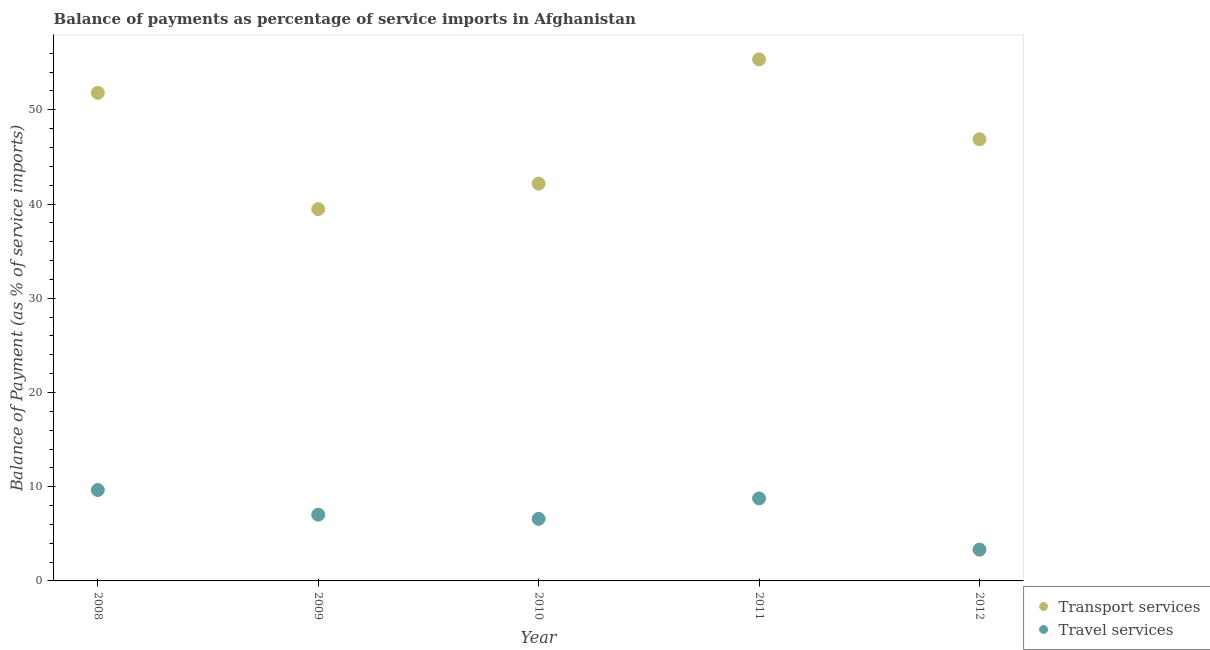Is the number of dotlines equal to the number of legend labels?
Keep it short and to the point. Yes. What is the balance of payments of transport services in 2008?
Give a very brief answer. 51.81. Across all years, what is the maximum balance of payments of travel services?
Ensure brevity in your answer.  9.65. Across all years, what is the minimum balance of payments of travel services?
Your response must be concise. 3.32. What is the total balance of payments of transport services in the graph?
Your response must be concise. 235.67. What is the difference between the balance of payments of travel services in 2008 and that in 2011?
Provide a short and direct response. 0.89. What is the difference between the balance of payments of transport services in 2012 and the balance of payments of travel services in 2009?
Offer a very short reply. 39.84. What is the average balance of payments of transport services per year?
Provide a succinct answer. 47.13. In the year 2012, what is the difference between the balance of payments of transport services and balance of payments of travel services?
Provide a short and direct response. 43.56. What is the ratio of the balance of payments of transport services in 2008 to that in 2010?
Ensure brevity in your answer.  1.23. Is the difference between the balance of payments of transport services in 2008 and 2009 greater than the difference between the balance of payments of travel services in 2008 and 2009?
Make the answer very short. Yes. What is the difference between the highest and the second highest balance of payments of travel services?
Give a very brief answer. 0.89. What is the difference between the highest and the lowest balance of payments of travel services?
Offer a terse response. 6.33. Is the sum of the balance of payments of travel services in 2009 and 2012 greater than the maximum balance of payments of transport services across all years?
Keep it short and to the point. No. Does the balance of payments of transport services monotonically increase over the years?
Offer a very short reply. No. Is the balance of payments of travel services strictly greater than the balance of payments of transport services over the years?
Provide a succinct answer. No. Is the balance of payments of travel services strictly less than the balance of payments of transport services over the years?
Offer a terse response. Yes. How many dotlines are there?
Keep it short and to the point. 2. Are the values on the major ticks of Y-axis written in scientific E-notation?
Offer a terse response. No. Does the graph contain grids?
Give a very brief answer. No. How are the legend labels stacked?
Give a very brief answer. Vertical. What is the title of the graph?
Make the answer very short. Balance of payments as percentage of service imports in Afghanistan. What is the label or title of the Y-axis?
Keep it short and to the point. Balance of Payment (as % of service imports). What is the Balance of Payment (as % of service imports) in Transport services in 2008?
Your response must be concise. 51.81. What is the Balance of Payment (as % of service imports) of Travel services in 2008?
Give a very brief answer. 9.65. What is the Balance of Payment (as % of service imports) in Transport services in 2009?
Offer a terse response. 39.46. What is the Balance of Payment (as % of service imports) in Travel services in 2009?
Offer a very short reply. 7.03. What is the Balance of Payment (as % of service imports) in Transport services in 2010?
Keep it short and to the point. 42.17. What is the Balance of Payment (as % of service imports) of Travel services in 2010?
Provide a succinct answer. 6.59. What is the Balance of Payment (as % of service imports) of Transport services in 2011?
Offer a terse response. 55.35. What is the Balance of Payment (as % of service imports) of Travel services in 2011?
Your response must be concise. 8.75. What is the Balance of Payment (as % of service imports) of Transport services in 2012?
Your response must be concise. 46.87. What is the Balance of Payment (as % of service imports) of Travel services in 2012?
Ensure brevity in your answer.  3.32. Across all years, what is the maximum Balance of Payment (as % of service imports) in Transport services?
Make the answer very short. 55.35. Across all years, what is the maximum Balance of Payment (as % of service imports) of Travel services?
Your response must be concise. 9.65. Across all years, what is the minimum Balance of Payment (as % of service imports) of Transport services?
Your answer should be compact. 39.46. Across all years, what is the minimum Balance of Payment (as % of service imports) of Travel services?
Provide a short and direct response. 3.32. What is the total Balance of Payment (as % of service imports) of Transport services in the graph?
Your answer should be compact. 235.67. What is the total Balance of Payment (as % of service imports) of Travel services in the graph?
Keep it short and to the point. 35.35. What is the difference between the Balance of Payment (as % of service imports) of Transport services in 2008 and that in 2009?
Your answer should be compact. 12.35. What is the difference between the Balance of Payment (as % of service imports) of Travel services in 2008 and that in 2009?
Offer a terse response. 2.62. What is the difference between the Balance of Payment (as % of service imports) of Transport services in 2008 and that in 2010?
Offer a very short reply. 9.64. What is the difference between the Balance of Payment (as % of service imports) in Travel services in 2008 and that in 2010?
Provide a succinct answer. 3.06. What is the difference between the Balance of Payment (as % of service imports) of Transport services in 2008 and that in 2011?
Make the answer very short. -3.55. What is the difference between the Balance of Payment (as % of service imports) of Travel services in 2008 and that in 2011?
Give a very brief answer. 0.89. What is the difference between the Balance of Payment (as % of service imports) in Transport services in 2008 and that in 2012?
Make the answer very short. 4.93. What is the difference between the Balance of Payment (as % of service imports) of Travel services in 2008 and that in 2012?
Your answer should be very brief. 6.33. What is the difference between the Balance of Payment (as % of service imports) of Transport services in 2009 and that in 2010?
Keep it short and to the point. -2.71. What is the difference between the Balance of Payment (as % of service imports) in Travel services in 2009 and that in 2010?
Your answer should be compact. 0.44. What is the difference between the Balance of Payment (as % of service imports) in Transport services in 2009 and that in 2011?
Your answer should be very brief. -15.89. What is the difference between the Balance of Payment (as % of service imports) in Travel services in 2009 and that in 2011?
Provide a short and direct response. -1.72. What is the difference between the Balance of Payment (as % of service imports) in Transport services in 2009 and that in 2012?
Offer a very short reply. -7.41. What is the difference between the Balance of Payment (as % of service imports) of Travel services in 2009 and that in 2012?
Provide a short and direct response. 3.71. What is the difference between the Balance of Payment (as % of service imports) in Transport services in 2010 and that in 2011?
Your answer should be compact. -13.18. What is the difference between the Balance of Payment (as % of service imports) of Travel services in 2010 and that in 2011?
Provide a short and direct response. -2.16. What is the difference between the Balance of Payment (as % of service imports) of Transport services in 2010 and that in 2012?
Ensure brevity in your answer.  -4.7. What is the difference between the Balance of Payment (as % of service imports) in Travel services in 2010 and that in 2012?
Give a very brief answer. 3.27. What is the difference between the Balance of Payment (as % of service imports) in Transport services in 2011 and that in 2012?
Keep it short and to the point. 8.48. What is the difference between the Balance of Payment (as % of service imports) of Travel services in 2011 and that in 2012?
Keep it short and to the point. 5.44. What is the difference between the Balance of Payment (as % of service imports) in Transport services in 2008 and the Balance of Payment (as % of service imports) in Travel services in 2009?
Your response must be concise. 44.78. What is the difference between the Balance of Payment (as % of service imports) in Transport services in 2008 and the Balance of Payment (as % of service imports) in Travel services in 2010?
Make the answer very short. 45.22. What is the difference between the Balance of Payment (as % of service imports) in Transport services in 2008 and the Balance of Payment (as % of service imports) in Travel services in 2011?
Your answer should be very brief. 43.05. What is the difference between the Balance of Payment (as % of service imports) in Transport services in 2008 and the Balance of Payment (as % of service imports) in Travel services in 2012?
Keep it short and to the point. 48.49. What is the difference between the Balance of Payment (as % of service imports) of Transport services in 2009 and the Balance of Payment (as % of service imports) of Travel services in 2010?
Offer a very short reply. 32.87. What is the difference between the Balance of Payment (as % of service imports) of Transport services in 2009 and the Balance of Payment (as % of service imports) of Travel services in 2011?
Keep it short and to the point. 30.71. What is the difference between the Balance of Payment (as % of service imports) of Transport services in 2009 and the Balance of Payment (as % of service imports) of Travel services in 2012?
Give a very brief answer. 36.14. What is the difference between the Balance of Payment (as % of service imports) in Transport services in 2010 and the Balance of Payment (as % of service imports) in Travel services in 2011?
Your response must be concise. 33.41. What is the difference between the Balance of Payment (as % of service imports) in Transport services in 2010 and the Balance of Payment (as % of service imports) in Travel services in 2012?
Offer a very short reply. 38.85. What is the difference between the Balance of Payment (as % of service imports) of Transport services in 2011 and the Balance of Payment (as % of service imports) of Travel services in 2012?
Your answer should be very brief. 52.04. What is the average Balance of Payment (as % of service imports) of Transport services per year?
Your answer should be compact. 47.13. What is the average Balance of Payment (as % of service imports) of Travel services per year?
Provide a short and direct response. 7.07. In the year 2008, what is the difference between the Balance of Payment (as % of service imports) in Transport services and Balance of Payment (as % of service imports) in Travel services?
Your answer should be compact. 42.16. In the year 2009, what is the difference between the Balance of Payment (as % of service imports) of Transport services and Balance of Payment (as % of service imports) of Travel services?
Make the answer very short. 32.43. In the year 2010, what is the difference between the Balance of Payment (as % of service imports) in Transport services and Balance of Payment (as % of service imports) in Travel services?
Your answer should be very brief. 35.58. In the year 2011, what is the difference between the Balance of Payment (as % of service imports) in Transport services and Balance of Payment (as % of service imports) in Travel services?
Keep it short and to the point. 46.6. In the year 2012, what is the difference between the Balance of Payment (as % of service imports) in Transport services and Balance of Payment (as % of service imports) in Travel services?
Offer a very short reply. 43.56. What is the ratio of the Balance of Payment (as % of service imports) in Transport services in 2008 to that in 2009?
Ensure brevity in your answer.  1.31. What is the ratio of the Balance of Payment (as % of service imports) of Travel services in 2008 to that in 2009?
Offer a very short reply. 1.37. What is the ratio of the Balance of Payment (as % of service imports) in Transport services in 2008 to that in 2010?
Provide a succinct answer. 1.23. What is the ratio of the Balance of Payment (as % of service imports) of Travel services in 2008 to that in 2010?
Your answer should be very brief. 1.46. What is the ratio of the Balance of Payment (as % of service imports) of Transport services in 2008 to that in 2011?
Your response must be concise. 0.94. What is the ratio of the Balance of Payment (as % of service imports) of Travel services in 2008 to that in 2011?
Offer a terse response. 1.1. What is the ratio of the Balance of Payment (as % of service imports) in Transport services in 2008 to that in 2012?
Offer a terse response. 1.11. What is the ratio of the Balance of Payment (as % of service imports) in Travel services in 2008 to that in 2012?
Give a very brief answer. 2.91. What is the ratio of the Balance of Payment (as % of service imports) of Transport services in 2009 to that in 2010?
Make the answer very short. 0.94. What is the ratio of the Balance of Payment (as % of service imports) in Travel services in 2009 to that in 2010?
Provide a short and direct response. 1.07. What is the ratio of the Balance of Payment (as % of service imports) in Transport services in 2009 to that in 2011?
Provide a short and direct response. 0.71. What is the ratio of the Balance of Payment (as % of service imports) of Travel services in 2009 to that in 2011?
Your answer should be compact. 0.8. What is the ratio of the Balance of Payment (as % of service imports) of Transport services in 2009 to that in 2012?
Your answer should be compact. 0.84. What is the ratio of the Balance of Payment (as % of service imports) of Travel services in 2009 to that in 2012?
Make the answer very short. 2.12. What is the ratio of the Balance of Payment (as % of service imports) in Transport services in 2010 to that in 2011?
Offer a very short reply. 0.76. What is the ratio of the Balance of Payment (as % of service imports) of Travel services in 2010 to that in 2011?
Ensure brevity in your answer.  0.75. What is the ratio of the Balance of Payment (as % of service imports) in Transport services in 2010 to that in 2012?
Your response must be concise. 0.9. What is the ratio of the Balance of Payment (as % of service imports) of Travel services in 2010 to that in 2012?
Give a very brief answer. 1.99. What is the ratio of the Balance of Payment (as % of service imports) in Transport services in 2011 to that in 2012?
Offer a very short reply. 1.18. What is the ratio of the Balance of Payment (as % of service imports) in Travel services in 2011 to that in 2012?
Keep it short and to the point. 2.64. What is the difference between the highest and the second highest Balance of Payment (as % of service imports) of Transport services?
Provide a short and direct response. 3.55. What is the difference between the highest and the second highest Balance of Payment (as % of service imports) of Travel services?
Ensure brevity in your answer.  0.89. What is the difference between the highest and the lowest Balance of Payment (as % of service imports) in Transport services?
Make the answer very short. 15.89. What is the difference between the highest and the lowest Balance of Payment (as % of service imports) in Travel services?
Your answer should be compact. 6.33. 